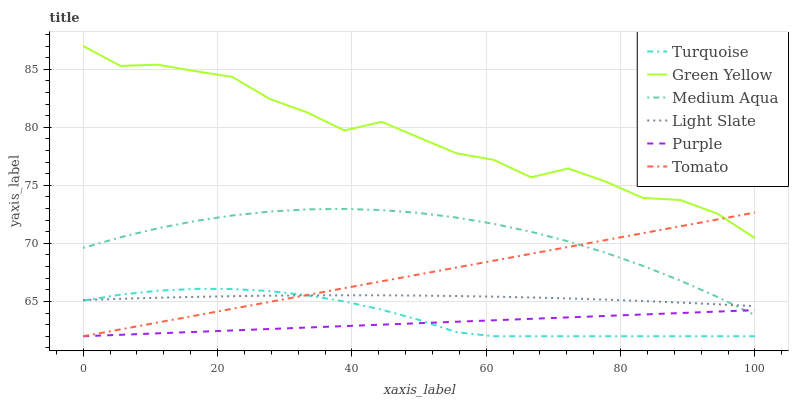Does Purple have the minimum area under the curve?
Answer yes or no. Yes. Does Green Yellow have the maximum area under the curve?
Answer yes or no. Yes. Does Turquoise have the minimum area under the curve?
Answer yes or no. No. Does Turquoise have the maximum area under the curve?
Answer yes or no. No. Is Purple the smoothest?
Answer yes or no. Yes. Is Green Yellow the roughest?
Answer yes or no. Yes. Is Turquoise the smoothest?
Answer yes or no. No. Is Turquoise the roughest?
Answer yes or no. No. Does Light Slate have the lowest value?
Answer yes or no. No. Does Turquoise have the highest value?
Answer yes or no. No. Is Purple less than Light Slate?
Answer yes or no. Yes. Is Green Yellow greater than Purple?
Answer yes or no. Yes. Does Purple intersect Light Slate?
Answer yes or no. No. 